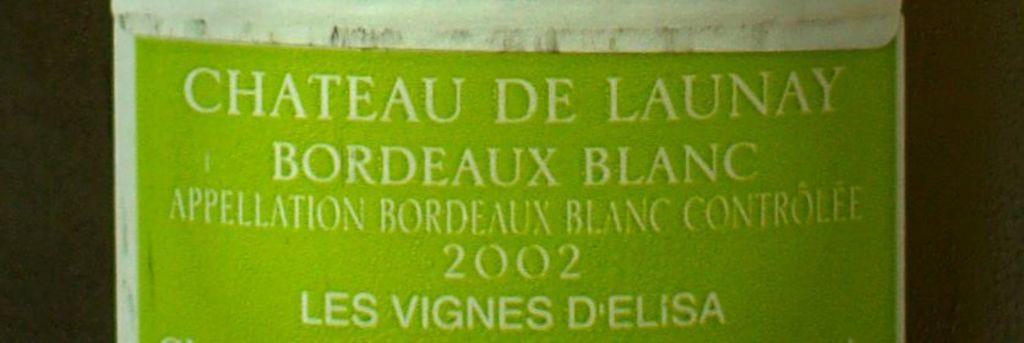<image>
Share a concise interpretation of the image provided. Green sign with white letters saying Chateau de launay. 